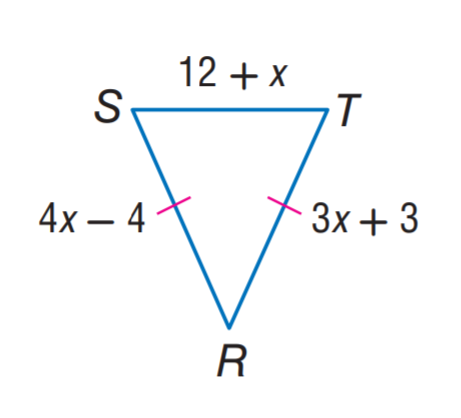Answer the mathemtical geometry problem and directly provide the correct option letter.
Question: Find x.
Choices: A: 3 B: 4 C: 7 D: 12 C 